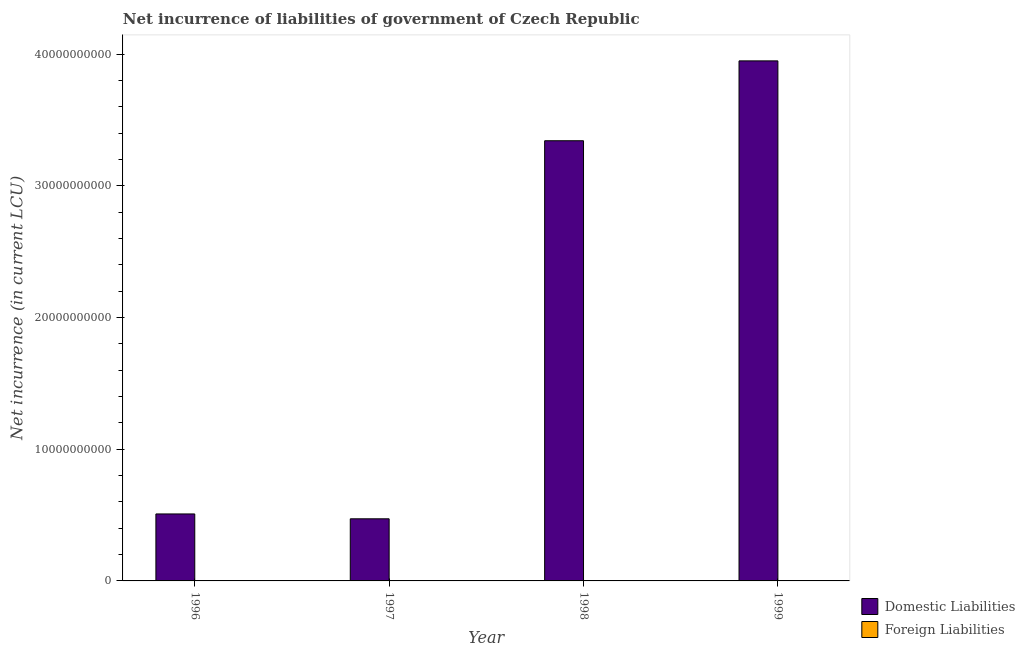How many different coloured bars are there?
Ensure brevity in your answer.  1. Are the number of bars per tick equal to the number of legend labels?
Keep it short and to the point. No. How many bars are there on the 3rd tick from the left?
Ensure brevity in your answer.  1. How many bars are there on the 2nd tick from the right?
Your answer should be compact. 1. What is the label of the 2nd group of bars from the left?
Offer a very short reply. 1997. What is the net incurrence of domestic liabilities in 1999?
Offer a very short reply. 3.95e+1. Across all years, what is the maximum net incurrence of domestic liabilities?
Your response must be concise. 3.95e+1. In which year was the net incurrence of domestic liabilities maximum?
Give a very brief answer. 1999. What is the difference between the net incurrence of domestic liabilities in 1996 and that in 1998?
Make the answer very short. -2.83e+1. What is the difference between the net incurrence of foreign liabilities in 1996 and the net incurrence of domestic liabilities in 1999?
Ensure brevity in your answer.  0. What is the average net incurrence of domestic liabilities per year?
Provide a short and direct response. 2.07e+1. In the year 1999, what is the difference between the net incurrence of domestic liabilities and net incurrence of foreign liabilities?
Ensure brevity in your answer.  0. What is the ratio of the net incurrence of domestic liabilities in 1996 to that in 1999?
Your answer should be very brief. 0.13. Is the net incurrence of domestic liabilities in 1997 less than that in 1998?
Make the answer very short. Yes. Is the difference between the net incurrence of domestic liabilities in 1998 and 1999 greater than the difference between the net incurrence of foreign liabilities in 1998 and 1999?
Offer a terse response. No. What is the difference between the highest and the second highest net incurrence of domestic liabilities?
Ensure brevity in your answer.  6.06e+09. What is the difference between the highest and the lowest net incurrence of domestic liabilities?
Keep it short and to the point. 3.48e+1. How many bars are there?
Provide a succinct answer. 4. Are the values on the major ticks of Y-axis written in scientific E-notation?
Provide a short and direct response. No. Does the graph contain any zero values?
Your answer should be very brief. Yes. Does the graph contain grids?
Your answer should be compact. No. How many legend labels are there?
Offer a terse response. 2. How are the legend labels stacked?
Offer a terse response. Vertical. What is the title of the graph?
Your answer should be very brief. Net incurrence of liabilities of government of Czech Republic. Does "Automatic Teller Machines" appear as one of the legend labels in the graph?
Your answer should be compact. No. What is the label or title of the X-axis?
Make the answer very short. Year. What is the label or title of the Y-axis?
Give a very brief answer. Net incurrence (in current LCU). What is the Net incurrence (in current LCU) of Domestic Liabilities in 1996?
Give a very brief answer. 5.08e+09. What is the Net incurrence (in current LCU) in Domestic Liabilities in 1997?
Give a very brief answer. 4.72e+09. What is the Net incurrence (in current LCU) in Domestic Liabilities in 1998?
Your answer should be very brief. 3.34e+1. What is the Net incurrence (in current LCU) of Foreign Liabilities in 1998?
Ensure brevity in your answer.  0. What is the Net incurrence (in current LCU) of Domestic Liabilities in 1999?
Offer a terse response. 3.95e+1. What is the Net incurrence (in current LCU) of Foreign Liabilities in 1999?
Offer a very short reply. 0. Across all years, what is the maximum Net incurrence (in current LCU) of Domestic Liabilities?
Provide a short and direct response. 3.95e+1. Across all years, what is the minimum Net incurrence (in current LCU) in Domestic Liabilities?
Ensure brevity in your answer.  4.72e+09. What is the total Net incurrence (in current LCU) of Domestic Liabilities in the graph?
Make the answer very short. 8.27e+1. What is the total Net incurrence (in current LCU) in Foreign Liabilities in the graph?
Ensure brevity in your answer.  0. What is the difference between the Net incurrence (in current LCU) in Domestic Liabilities in 1996 and that in 1997?
Offer a terse response. 3.69e+08. What is the difference between the Net incurrence (in current LCU) in Domestic Liabilities in 1996 and that in 1998?
Offer a very short reply. -2.83e+1. What is the difference between the Net incurrence (in current LCU) of Domestic Liabilities in 1996 and that in 1999?
Your answer should be compact. -3.44e+1. What is the difference between the Net incurrence (in current LCU) in Domestic Liabilities in 1997 and that in 1998?
Provide a succinct answer. -2.87e+1. What is the difference between the Net incurrence (in current LCU) in Domestic Liabilities in 1997 and that in 1999?
Your response must be concise. -3.48e+1. What is the difference between the Net incurrence (in current LCU) of Domestic Liabilities in 1998 and that in 1999?
Ensure brevity in your answer.  -6.06e+09. What is the average Net incurrence (in current LCU) of Domestic Liabilities per year?
Provide a succinct answer. 2.07e+1. What is the ratio of the Net incurrence (in current LCU) in Domestic Liabilities in 1996 to that in 1997?
Offer a very short reply. 1.08. What is the ratio of the Net incurrence (in current LCU) in Domestic Liabilities in 1996 to that in 1998?
Give a very brief answer. 0.15. What is the ratio of the Net incurrence (in current LCU) of Domestic Liabilities in 1996 to that in 1999?
Offer a terse response. 0.13. What is the ratio of the Net incurrence (in current LCU) of Domestic Liabilities in 1997 to that in 1998?
Give a very brief answer. 0.14. What is the ratio of the Net incurrence (in current LCU) in Domestic Liabilities in 1997 to that in 1999?
Your answer should be compact. 0.12. What is the ratio of the Net incurrence (in current LCU) in Domestic Liabilities in 1998 to that in 1999?
Make the answer very short. 0.85. What is the difference between the highest and the second highest Net incurrence (in current LCU) in Domestic Liabilities?
Make the answer very short. 6.06e+09. What is the difference between the highest and the lowest Net incurrence (in current LCU) of Domestic Liabilities?
Make the answer very short. 3.48e+1. 